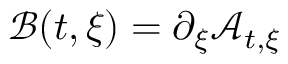<formula> <loc_0><loc_0><loc_500><loc_500>\mathcal { B } ( t , \xi ) = \partial _ { \xi } \mathcal { A } _ { t , \xi }</formula> 